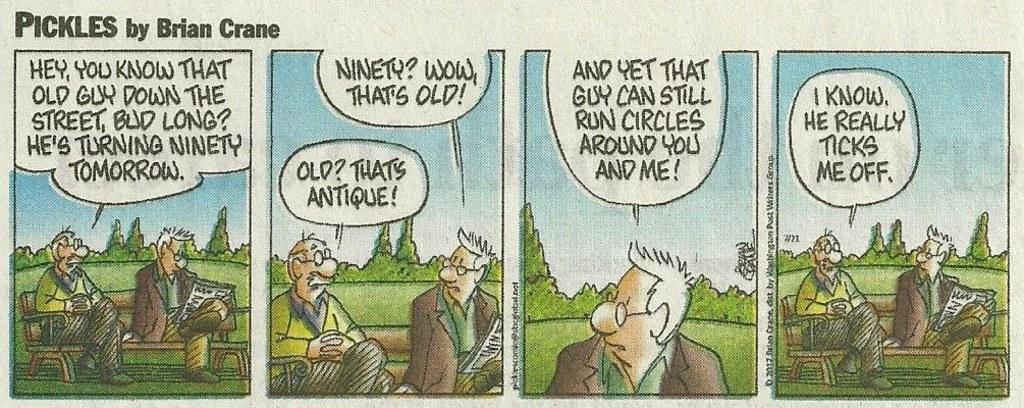Describe this image in one or two sentences. In this image we can see a poster, on the we can see some persons sitting on the benches, in the background, we can see some text and the sky with clouds. 